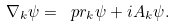<formula> <loc_0><loc_0><loc_500><loc_500>\nabla _ { k } \psi = \ p r _ { k } \psi + i A _ { k } \psi .</formula> 